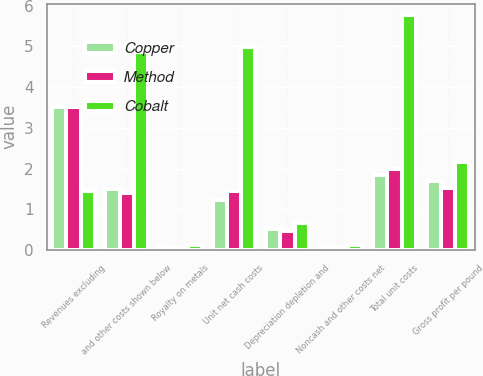Convert chart to OTSL. <chart><loc_0><loc_0><loc_500><loc_500><stacked_bar_chart><ecel><fcel>Revenues excluding<fcel>and other costs shown below<fcel>Royalty on metals<fcel>Unit net cash costs<fcel>Depreciation depletion and<fcel>Noncash and other costs net<fcel>Total unit costs<fcel>Gross profit per pound<nl><fcel>Copper<fcel>3.51<fcel>1.49<fcel>0.07<fcel>1.23<fcel>0.52<fcel>0.09<fcel>1.84<fcel>1.69<nl><fcel>Method<fcel>3.51<fcel>1.39<fcel>0.06<fcel>1.45<fcel>0.47<fcel>0.08<fcel>2<fcel>1.53<nl><fcel>Cobalt<fcel>1.45<fcel>4.86<fcel>0.12<fcel>4.98<fcel>0.67<fcel>0.11<fcel>5.76<fcel>2.16<nl></chart> 